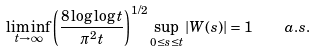Convert formula to latex. <formula><loc_0><loc_0><loc_500><loc_500>\liminf _ { t \to \infty } \left ( \frac { 8 \log \log t } { \pi ^ { 2 } t } \right ) ^ { 1 / 2 } \sup _ { 0 \leq s \leq t } | W ( s ) | = 1 \quad a . s .</formula> 